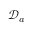<formula> <loc_0><loc_0><loc_500><loc_500>\mathcal { D } _ { a }</formula> 